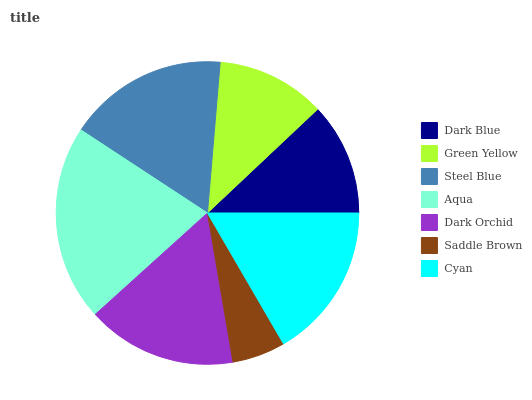Is Saddle Brown the minimum?
Answer yes or no. Yes. Is Aqua the maximum?
Answer yes or no. Yes. Is Green Yellow the minimum?
Answer yes or no. No. Is Green Yellow the maximum?
Answer yes or no. No. Is Dark Blue greater than Green Yellow?
Answer yes or no. Yes. Is Green Yellow less than Dark Blue?
Answer yes or no. Yes. Is Green Yellow greater than Dark Blue?
Answer yes or no. No. Is Dark Blue less than Green Yellow?
Answer yes or no. No. Is Dark Orchid the high median?
Answer yes or no. Yes. Is Dark Orchid the low median?
Answer yes or no. Yes. Is Dark Blue the high median?
Answer yes or no. No. Is Dark Blue the low median?
Answer yes or no. No. 